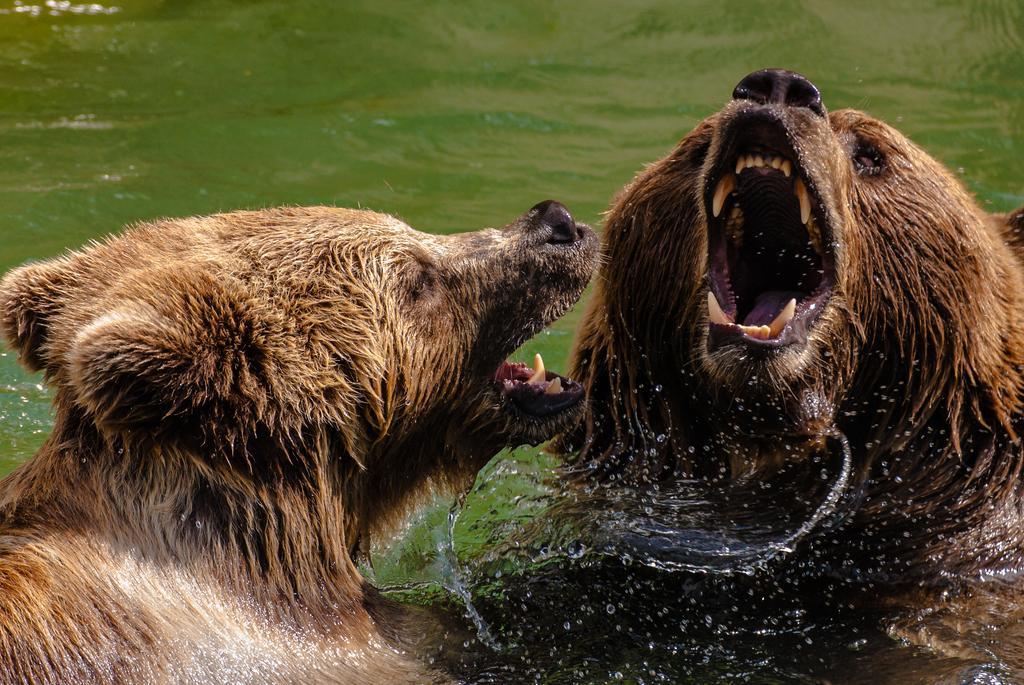Can you describe this image briefly? Here we can see two animals and this is water. 